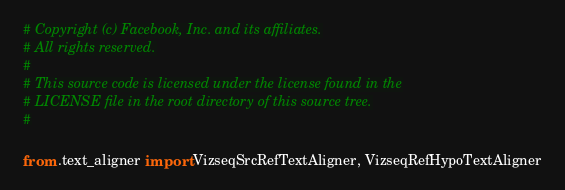<code> <loc_0><loc_0><loc_500><loc_500><_Python_># Copyright (c) Facebook, Inc. and its affiliates.
# All rights reserved.
#
# This source code is licensed under the license found in the
# LICENSE file in the root directory of this source tree.
#

from .text_aligner import VizseqSrcRefTextAligner, VizseqRefHypoTextAligner
</code> 